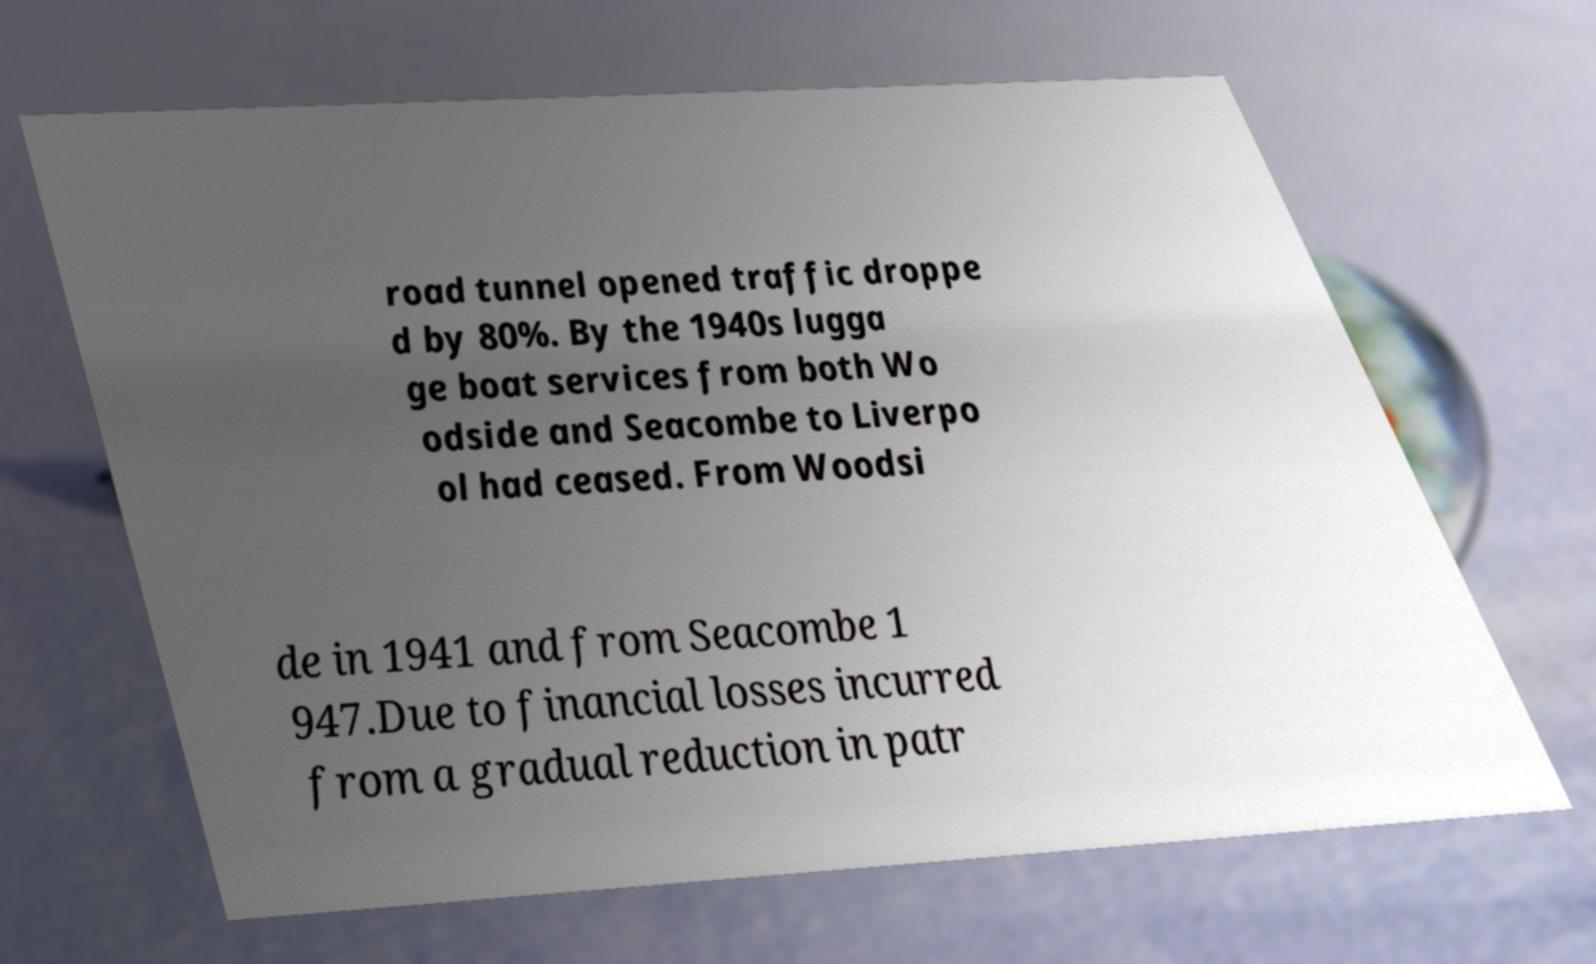What messages or text are displayed in this image? I need them in a readable, typed format. road tunnel opened traffic droppe d by 80%. By the 1940s lugga ge boat services from both Wo odside and Seacombe to Liverpo ol had ceased. From Woodsi de in 1941 and from Seacombe 1 947.Due to financial losses incurred from a gradual reduction in patr 